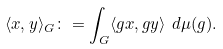<formula> <loc_0><loc_0><loc_500><loc_500>\langle x , y \rangle _ { G } \colon = \int _ { G } \langle g x , g y \rangle \ d \mu ( g ) .</formula> 